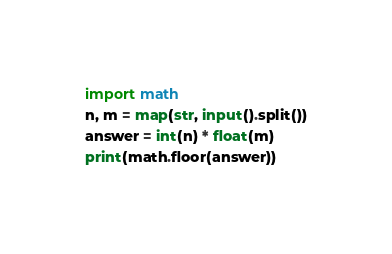<code> <loc_0><loc_0><loc_500><loc_500><_Python_>import math
n, m = map(str, input().split())
answer = int(n) * float(m)
print(math.floor(answer))</code> 